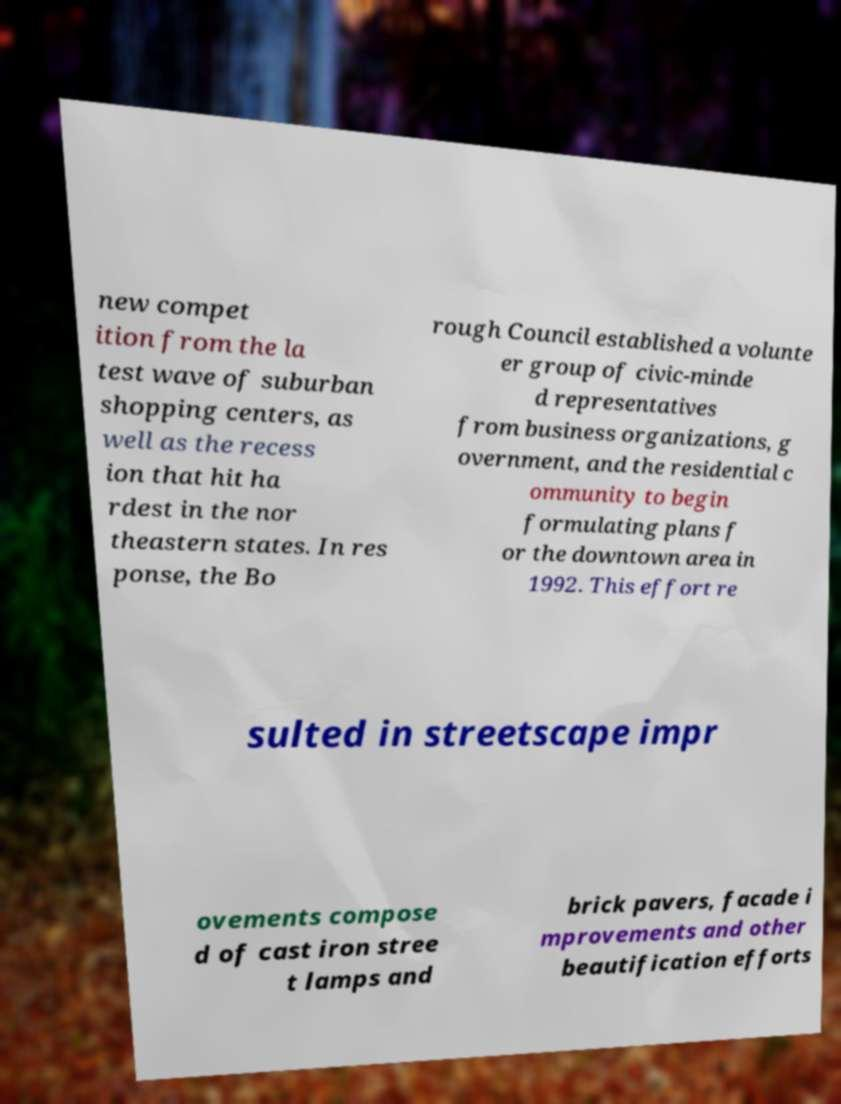Could you extract and type out the text from this image? new compet ition from the la test wave of suburban shopping centers, as well as the recess ion that hit ha rdest in the nor theastern states. In res ponse, the Bo rough Council established a volunte er group of civic-minde d representatives from business organizations, g overnment, and the residential c ommunity to begin formulating plans f or the downtown area in 1992. This effort re sulted in streetscape impr ovements compose d of cast iron stree t lamps and brick pavers, facade i mprovements and other beautification efforts 